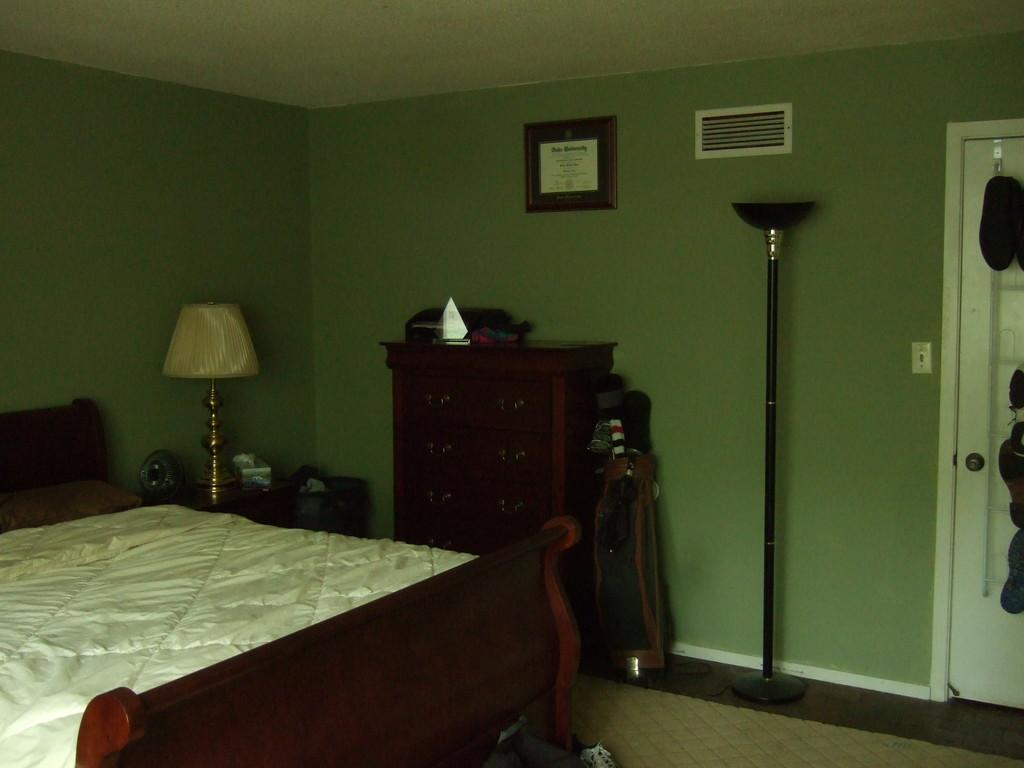What type of room is shown in the image? The image depicts a bedroom. What furniture is present in the bedroom? There is a bed, a cupboard, and a lamp in the room. What is on the bed? There is a bed sheet on the bed. Can you describe the decoration or accessory in the room? There is a photo in the room. How can the room be accessed or exited? There is a door in the room. What is attached to the door? There are things attached to the door. What type of amusement can be seen in the room? There is no amusement present in the room; it is a bedroom with a bed, cupboard, lamp, bed sheet, photo, and door. What unit of measurement is used to describe the size of the nail in the room? There is no mention of a nail in the room, so it is not possible to determine the unit of measurement used to describe its size. 